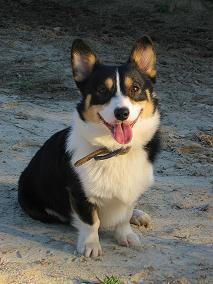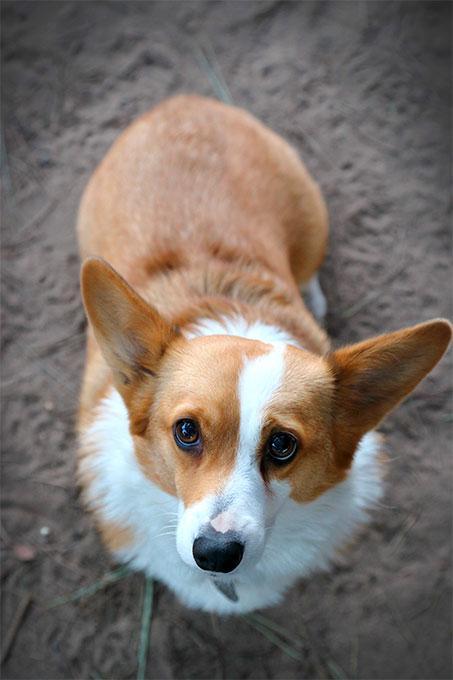The first image is the image on the left, the second image is the image on the right. Considering the images on both sides, is "the left image has a sitting dog with its' tongue out" valid? Answer yes or no. Yes. The first image is the image on the left, the second image is the image on the right. Considering the images on both sides, is "One dog is looking to the right." valid? Answer yes or no. No. 